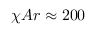Convert formula to latex. <formula><loc_0><loc_0><loc_500><loc_500>\chi A r \approx 2 0 0</formula> 